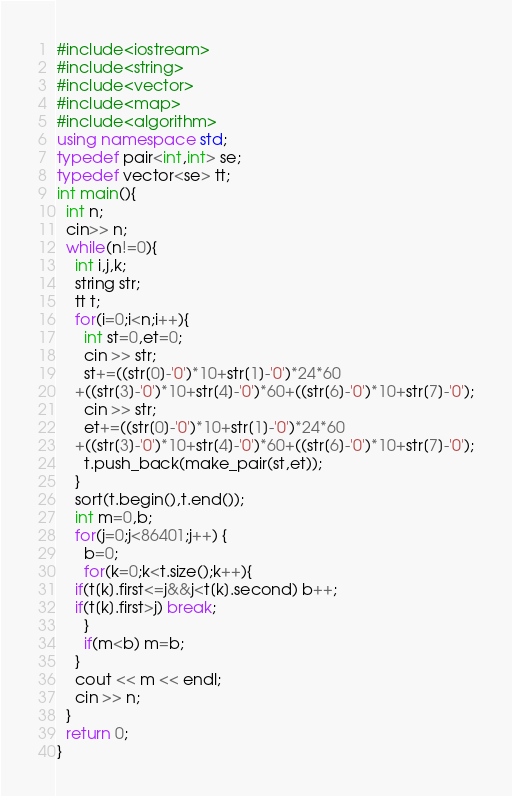Convert code to text. <code><loc_0><loc_0><loc_500><loc_500><_C++_>#include<iostream>
#include<string>
#include<vector>
#include<map>
#include<algorithm>
using namespace std;
typedef pair<int,int> se;
typedef vector<se> tt;
int main(){
  int n;
  cin>> n;
  while(n!=0){
    int i,j,k;
    string str;
    tt t;
    for(i=0;i<n;i++){
      int st=0,et=0;
      cin >> str;
      st+=((str[0]-'0')*10+str[1]-'0')*24*60
	+((str[3]-'0')*10+str[4]-'0')*60+((str[6]-'0')*10+str[7]-'0');
      cin >> str;
      et+=((str[0]-'0')*10+str[1]-'0')*24*60
	+((str[3]-'0')*10+str[4]-'0')*60+((str[6]-'0')*10+str[7]-'0');
      t.push_back(make_pair(st,et));
    }
    sort(t.begin(),t.end());
    int m=0,b;
    for(j=0;j<86401;j++) {
      b=0;
      for(k=0;k<t.size();k++){
	if(t[k].first<=j&&j<t[k].second) b++;
	if(t[k].first>j) break;
      }
      if(m<b) m=b;
    }
    cout << m << endl;
    cin >> n;
  }
  return 0;
}</code> 